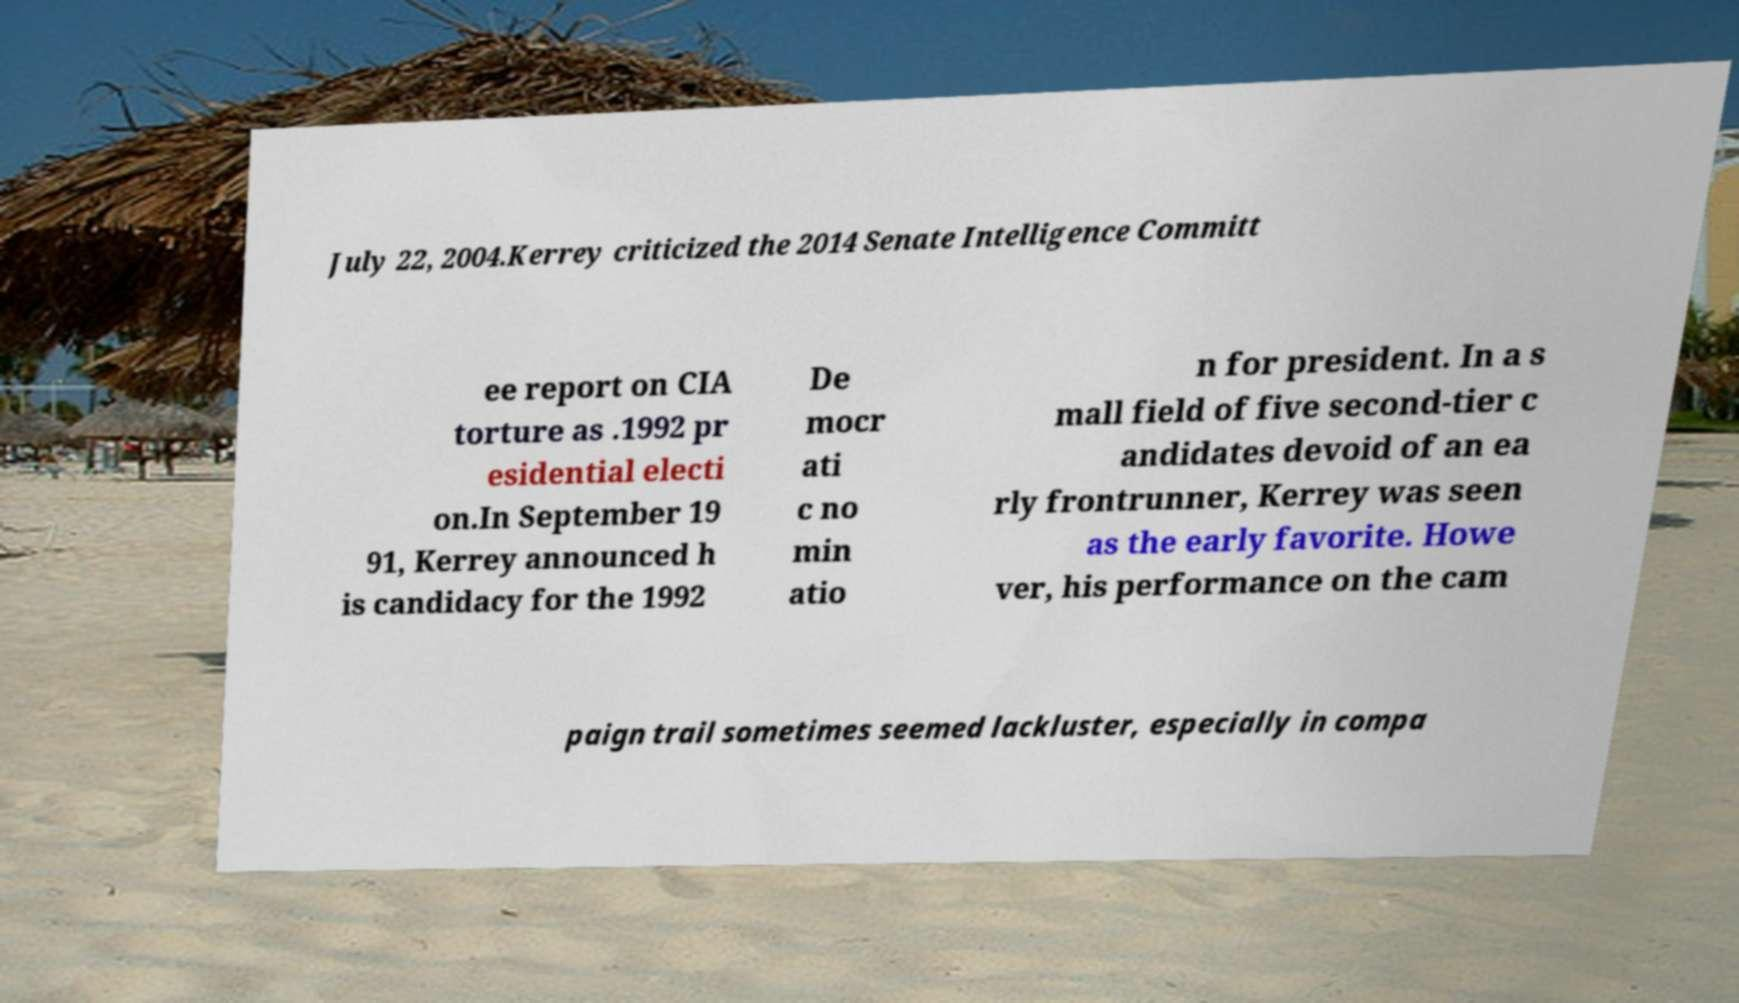I need the written content from this picture converted into text. Can you do that? July 22, 2004.Kerrey criticized the 2014 Senate Intelligence Committ ee report on CIA torture as .1992 pr esidential electi on.In September 19 91, Kerrey announced h is candidacy for the 1992 De mocr ati c no min atio n for president. In a s mall field of five second-tier c andidates devoid of an ea rly frontrunner, Kerrey was seen as the early favorite. Howe ver, his performance on the cam paign trail sometimes seemed lackluster, especially in compa 